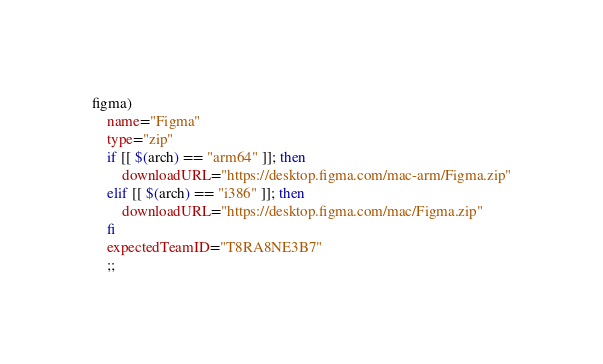<code> <loc_0><loc_0><loc_500><loc_500><_Bash_>figma)
    name="Figma"
    type="zip"
    if [[ $(arch) == "arm64" ]]; then
        downloadURL="https://desktop.figma.com/mac-arm/Figma.zip"
    elif [[ $(arch) == "i386" ]]; then
        downloadURL="https://desktop.figma.com/mac/Figma.zip"
    fi
    expectedTeamID="T8RA8NE3B7"
    ;;
</code> 